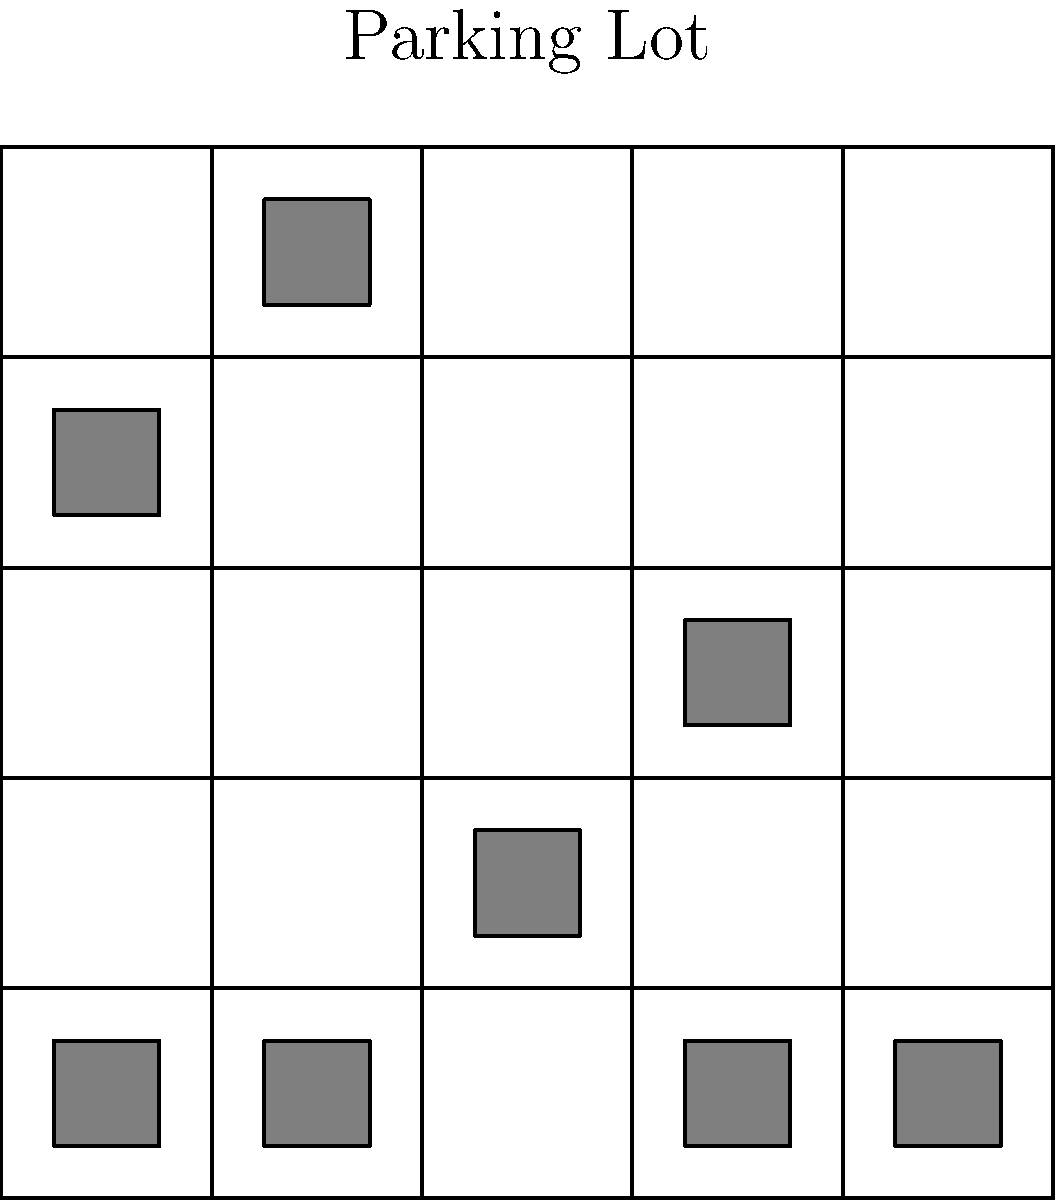Based on the overhead image of a parking lot, how many parking spaces are available for shoppers visiting the new mall in Cebu City? To determine the number of available parking spaces, we need to follow these steps:

1. Count the total number of parking spaces:
   The parking lot is a 5x5 grid, so there are 5 * 5 = 25 total spaces.

2. Count the number of occupied spaces:
   We can see 8 gray rectangles representing parked cars in the image.

3. Calculate the number of available spaces:
   Available spaces = Total spaces - Occupied spaces
   $$ 25 - 8 = 17 $$

Therefore, there are 17 parking spaces available for shoppers visiting the new mall in Cebu City.
Answer: 17 spaces 